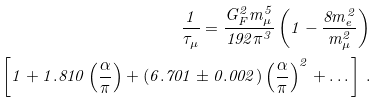Convert formula to latex. <formula><loc_0><loc_0><loc_500><loc_500>\frac { 1 } { \tau _ { \mu } } = \frac { G ^ { 2 } _ { F } m _ { \mu } ^ { 5 } } { 1 9 2 \pi ^ { 3 } } \left ( 1 - \frac { 8 m _ { e } ^ { 2 } } { m ^ { 2 } _ { \mu } } \right ) \\ \left [ 1 + 1 . 8 1 0 \left ( \frac { \alpha } { \pi } \right ) + ( 6 . 7 0 1 \pm 0 . 0 0 2 ) \left ( \frac { \alpha } { \pi } \right ) ^ { 2 } + \dots \right ] \, .</formula> 